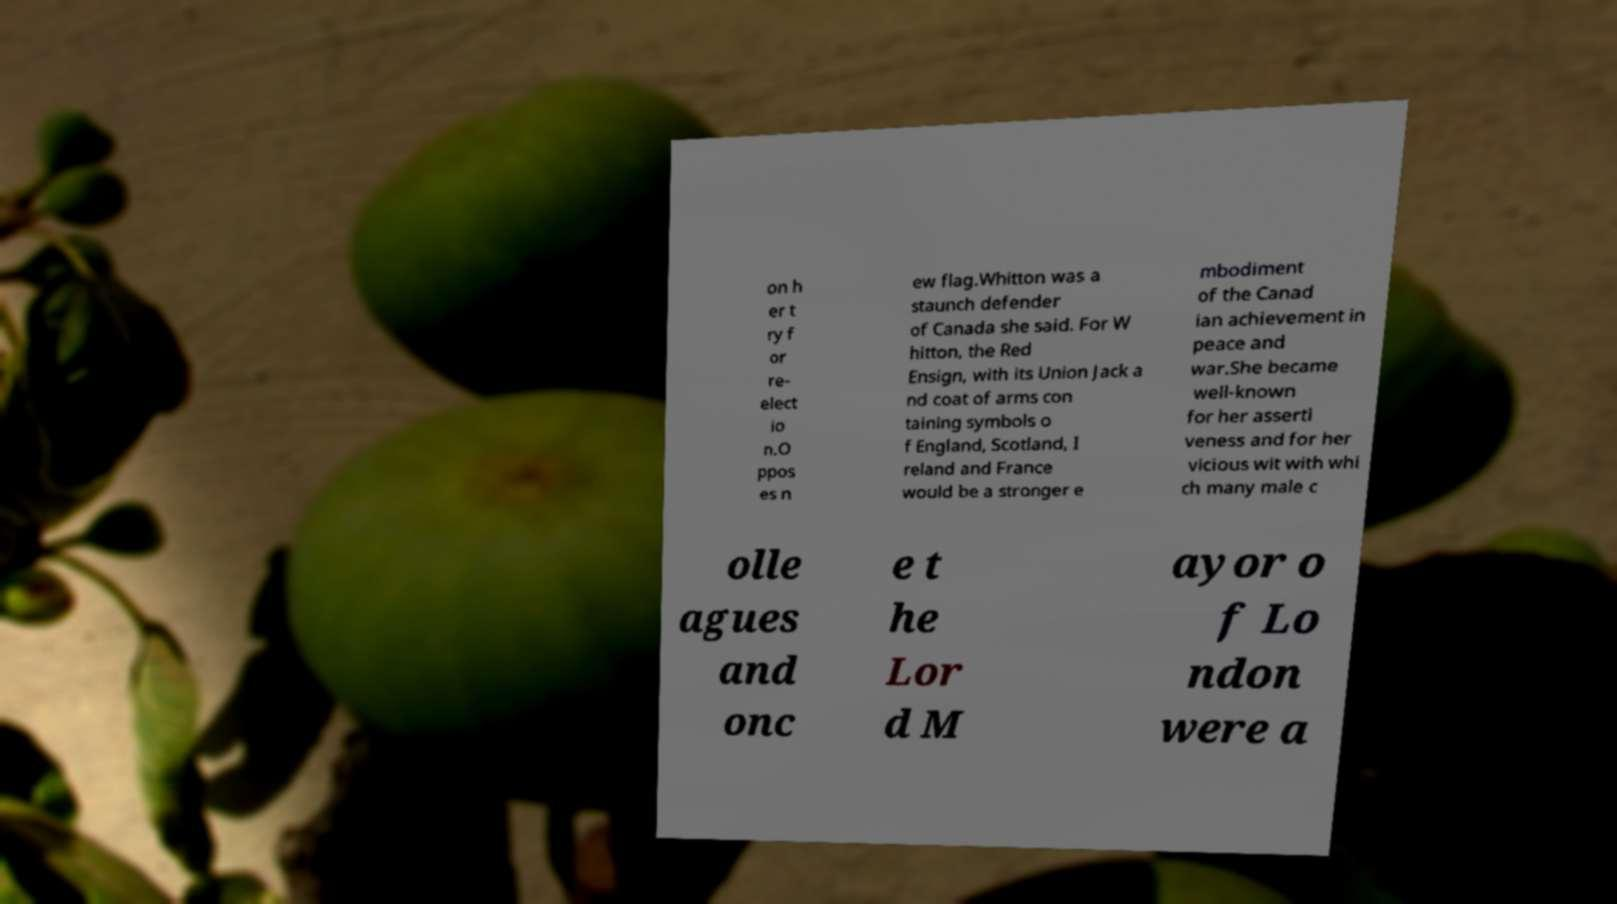What messages or text are displayed in this image? I need them in a readable, typed format. on h er t ry f or re- elect io n.O ppos es n ew flag.Whitton was a staunch defender of Canada she said. For W hitton, the Red Ensign, with its Union Jack a nd coat of arms con taining symbols o f England, Scotland, I reland and France would be a stronger e mbodiment of the Canad ian achievement in peace and war.She became well-known for her asserti veness and for her vicious wit with whi ch many male c olle agues and onc e t he Lor d M ayor o f Lo ndon were a 